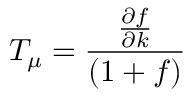Convert formula to latex. <formula><loc_0><loc_0><loc_500><loc_500>T _ { \mu } = \frac { \frac { \partial f } { \partial k } } { ( 1 + f ) }</formula> 